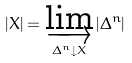<formula> <loc_0><loc_0><loc_500><loc_500>| X | = \varinjlim _ { \Delta ^ { n } \downarrow X } | \Delta ^ { n } |</formula> 